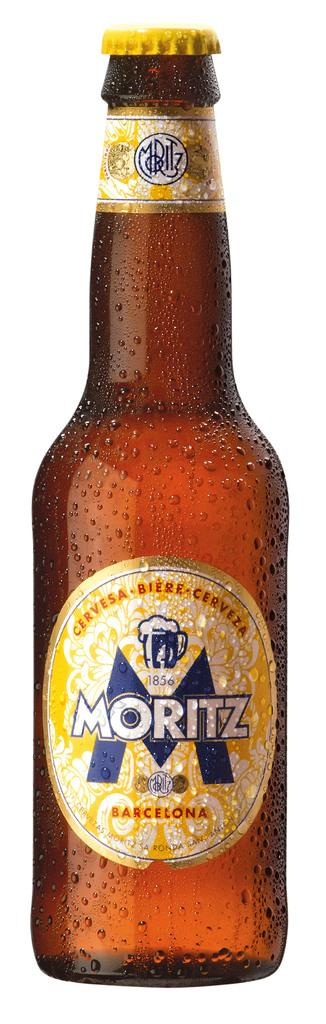Provide a one-sentence caption for the provided image. bottle of sweating cold yellow label barcelona moritz beer. 